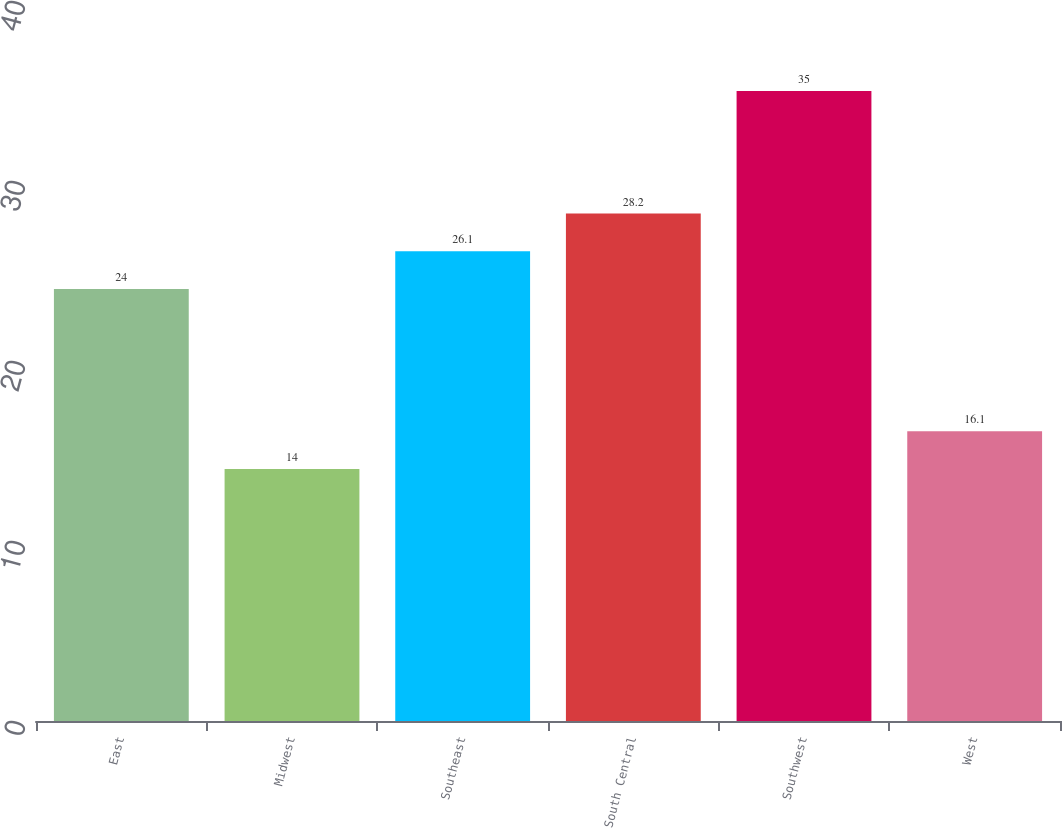<chart> <loc_0><loc_0><loc_500><loc_500><bar_chart><fcel>East<fcel>Midwest<fcel>Southeast<fcel>South Central<fcel>Southwest<fcel>West<nl><fcel>24<fcel>14<fcel>26.1<fcel>28.2<fcel>35<fcel>16.1<nl></chart> 